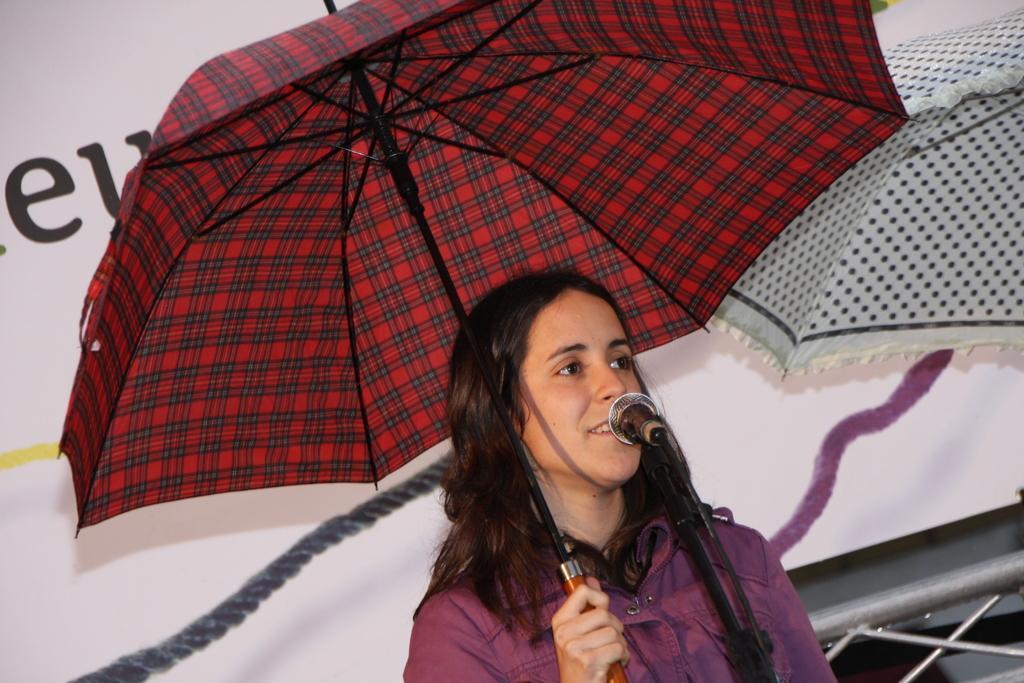In one or two sentences, can you explain what this image depicts? In this image there is a girl standing in front of a mic and holding an umbrella in her hand, in the background there is poster, on that poster there is text, in the top right there is an umbrella. 